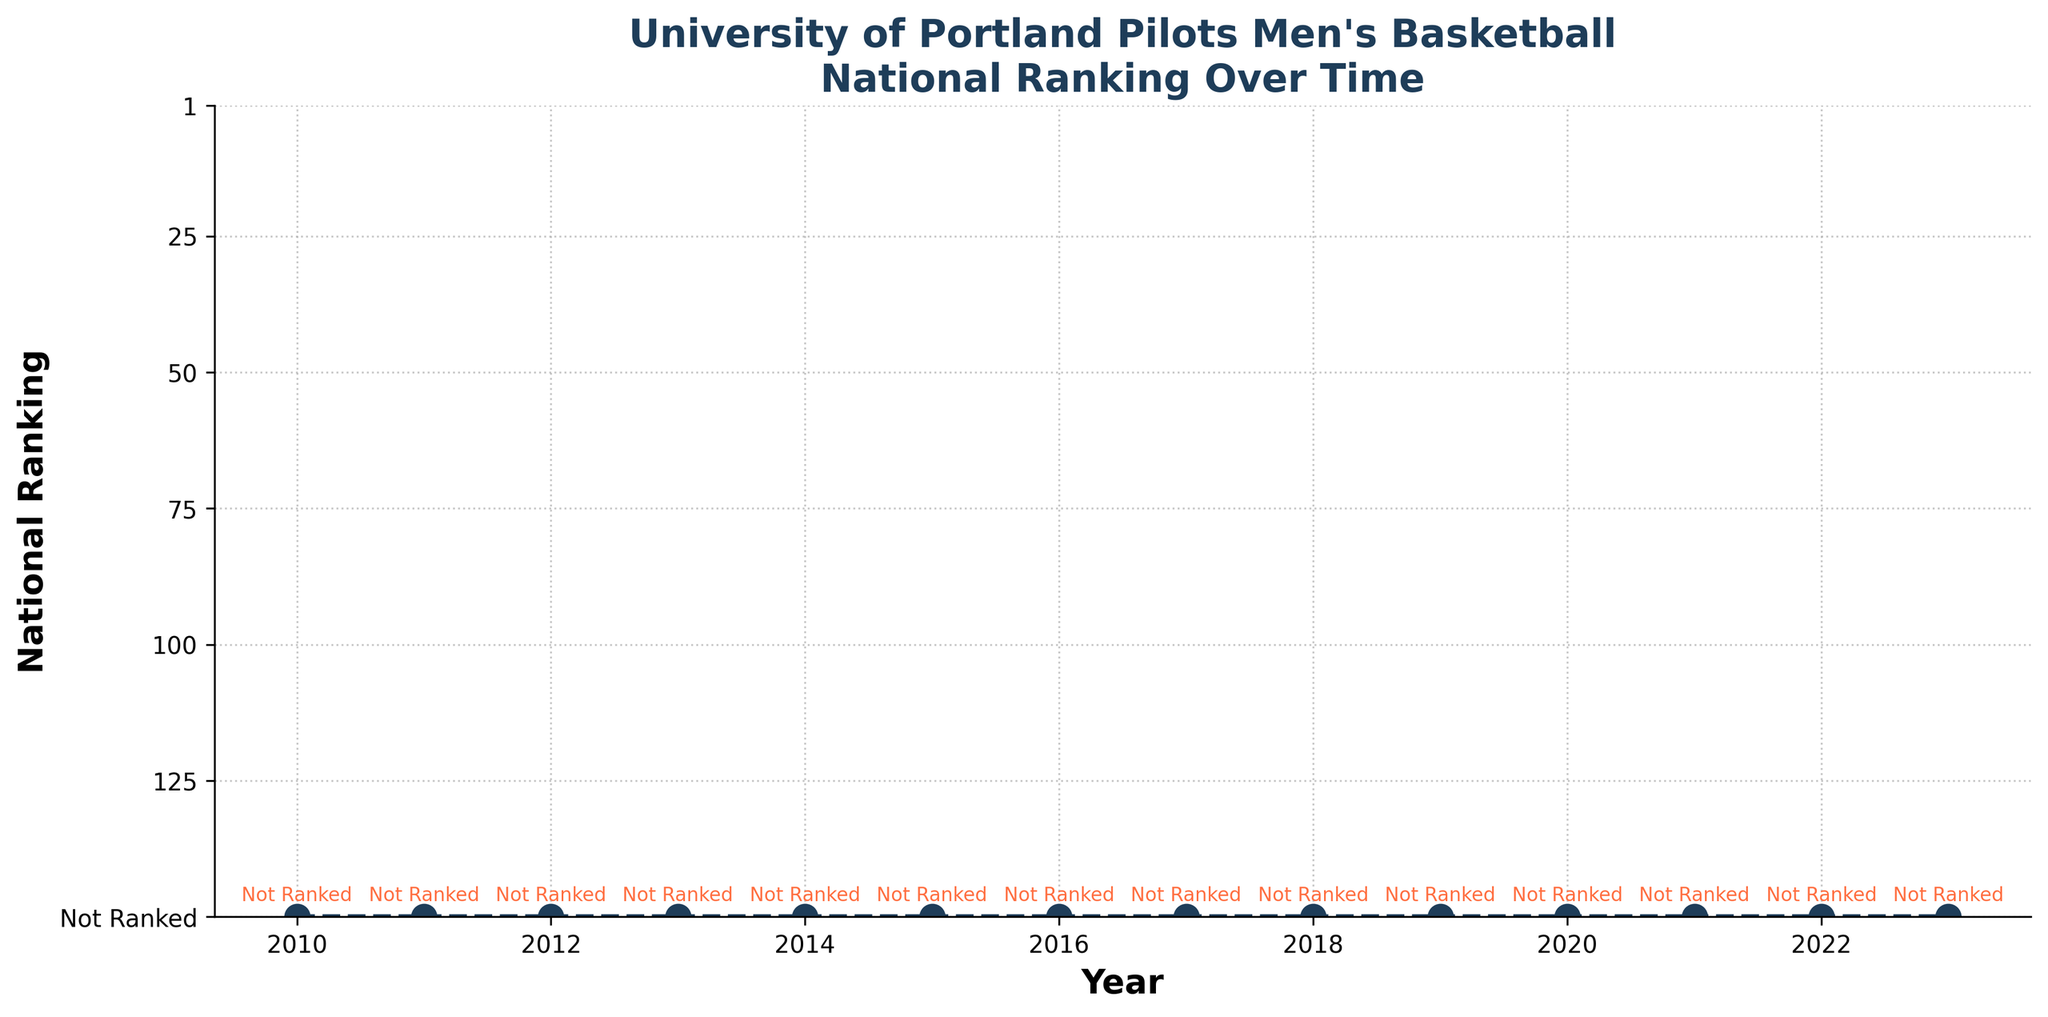What is the highest ranking achieved by the University of Portland Pilots men's basketball team according to the figure? According to the figure, the Pilots are always marked as "Not Ranked," which is visually represented at the bottom of the chart. Therefore, the highest ranking achieved is "Not Ranked."
Answer: Not Ranked How many years are represented in the figure for the University of Portland Pilots' national ranking? The x-axis labels denote the years, starting from 2010 and ending in 2023. Counting all the years between, there are 14 years represented in the figure.
Answer: 14 Compare the national ranking of the University of Portland Pilots from 2010 to 2015 with the ranking from 2018 to 2023. Are there any differences? From 2010 to 2015, as well as from 2018 to 2023, the Pilots are consistently "Not Ranked." Visually, their position on the y-axis does not change over these periods.
Answer: No differences In which year did the University of Portland Pilots have a national ranking position lower than 100? The y-axis indicates "Not Ranked" as the position, visually represented below 150. Hence, there is no year where their ranking position was lower than 100.
Answer: None What's the median ranking position for the University of Portland Pilots within the period shown in the chart? All points are represented as "Not Ranked." Since they are all at the same ranking level, the median ranking position is also "Not Ranked."
Answer: Not Ranked What color is used to annotate the "Not Ranked" status for each year in the figure? The color used to annotate "Not Ranked" for each year is mentioned in the explanation as being orange ("#ff6e40"), which appears visually consistent across the years.
Answer: Orange How does the line style used to represent the national ranking change throughout the years? The line style used in the figure is consistently a dashed line with markers at each year point, maintaining the same style throughout the chart.
Answer: No change What is the visual trend shown in the figure for the University of Portland Pilots men's basketball team's rankings over the years? The visual trend is flat and constant with the Pilots always being at the "Not Ranked" position from 2010 to 2023 without any change.
Answer: Constant Is there any year in which the University of Portland Pilots are ranked below the 150th position? As per the figure, "Not Ranked" is visually represented below the 150th position, implying they are always in the "Not Ranked" category and never ranked below 150.
Answer: No What do the gridlines represent in the figure, and how do they help in interpreting the chart? The gridlines are evenly spaced and correspond to y-axis labels (1, 25, 50, 75, 100, 125, and Not Ranked). They help the viewer easily compare each year's ranking position relative to these benchmarks.
Answer: Comparison assistance 